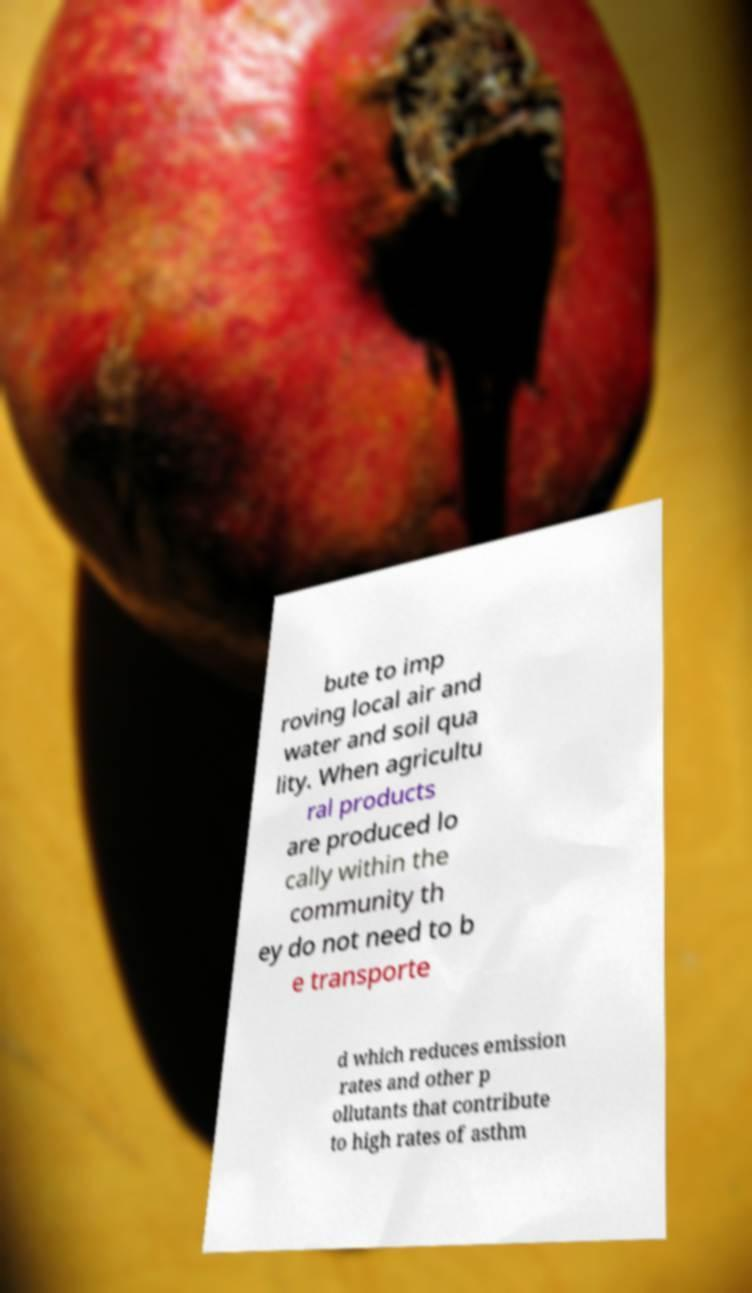Please identify and transcribe the text found in this image. bute to imp roving local air and water and soil qua lity. When agricultu ral products are produced lo cally within the community th ey do not need to b e transporte d which reduces emission rates and other p ollutants that contribute to high rates of asthm 